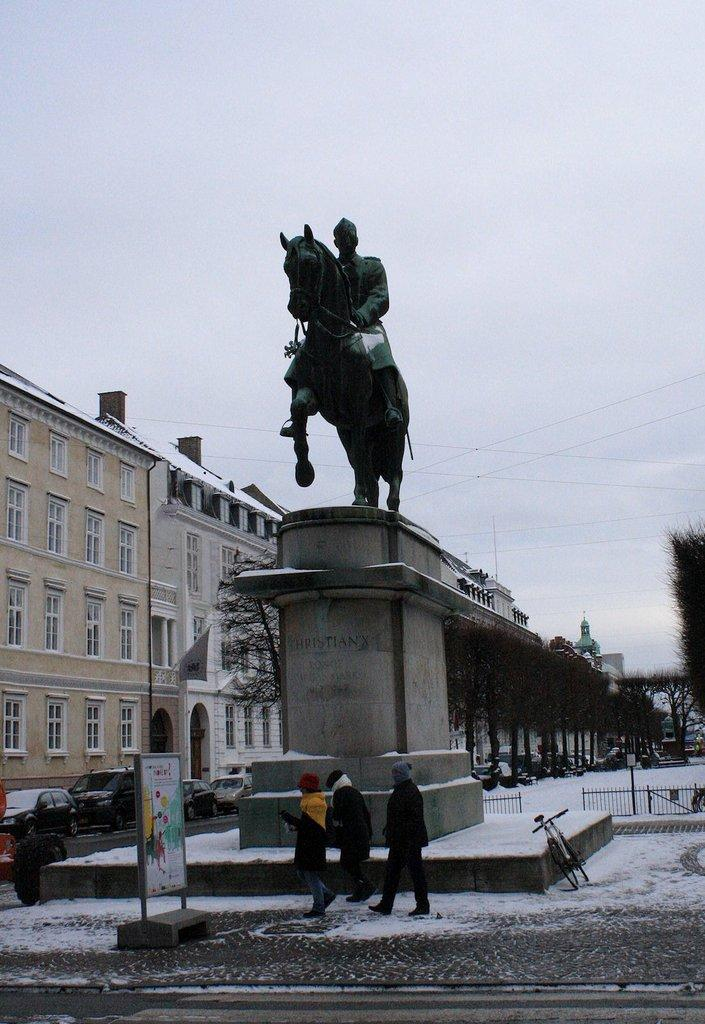What is the main subject of the image? The main subject of the image is a statue. Where is the statue located? The statue is on a pedestal. What else can be seen in the image besides the statue? There are grills, persons standing on the road, an advertisement board, motor vehicles, trees, cables, buildings, and the sky visible in the image. What is the condition of the sky in the image? The sky is visible in the image, and clouds are present. How many rings are being worn by the man in the image? There is no man present in the image, and therefore no rings can be observed. What type of basket is being used by the persons in the image? There are no baskets present in the image; the persons are standing on the road without any visible baskets. 